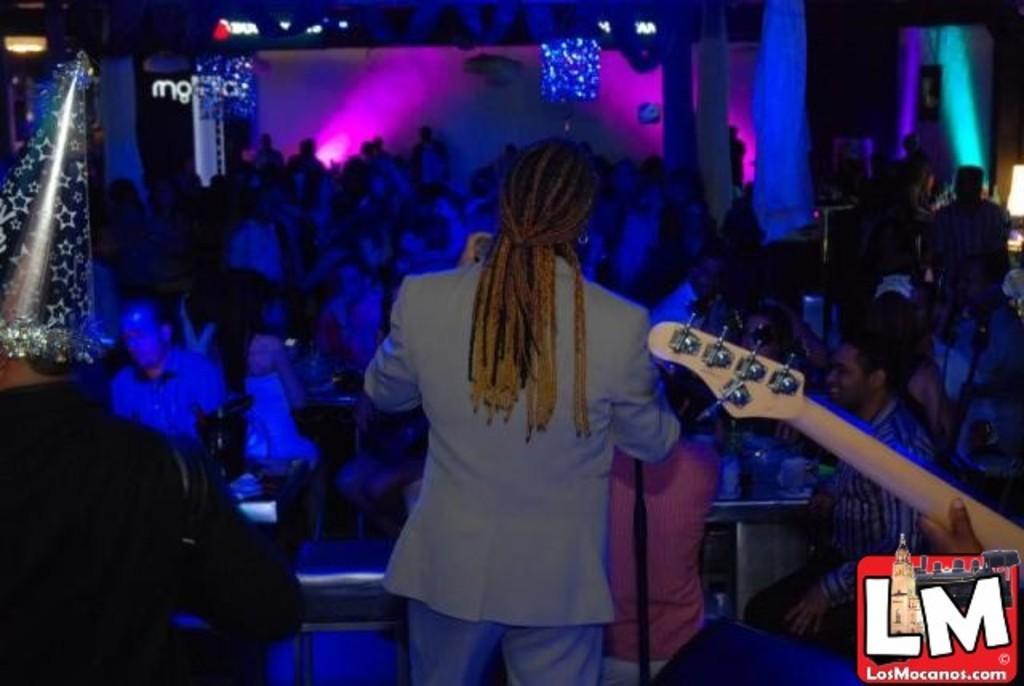Please provide a concise description of this image. This image is clicked in a musical concert. There are so many people in this image. On the left side right side and top there are lights. On the right side we can see a guitar and there is a person in the middle who is holding a mike. There are pink and blue lights. 